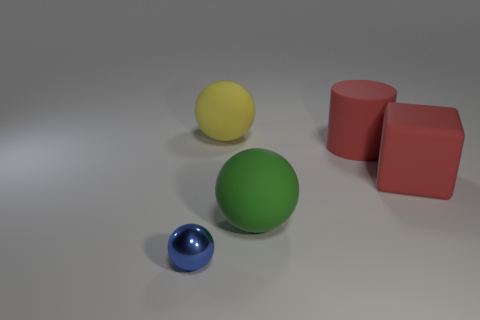How many objects in total are there, and can you describe their colors and shapes? There are four objects in total. Starting from the left, there is a yellow sphere, a blue shiny sphere, a large green sphere, and two red identical cubes on the right. 